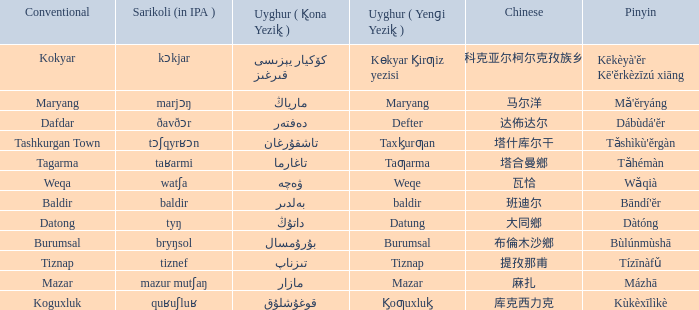Name the pinyin for  kɵkyar k̡irƣiz yezisi Kēkèyà'ěr Kē'ěrkèzīzú xiāng. 